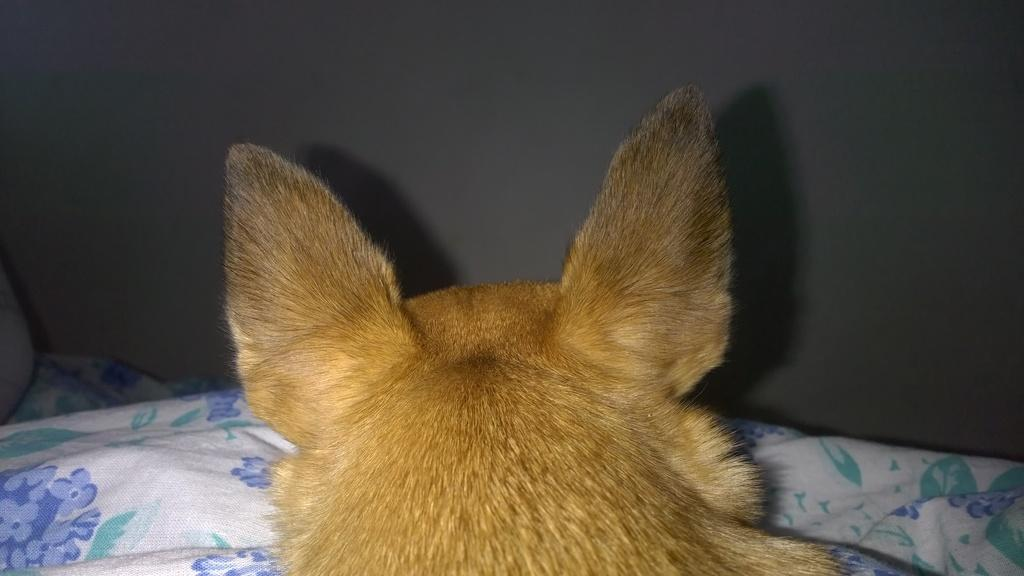What type of animal is in the image that resembles a dog? There is an animal in the image that resembles a dog. What is the animal sitting or lying on? The animal is on a cloth. What can be seen in the background of the image? There is a wall in the background of the image. What type of texture does the animal's tail have in the image? There is no mention of a tail in the provided facts, so we cannot determine the texture of the animal's tail from the image. 